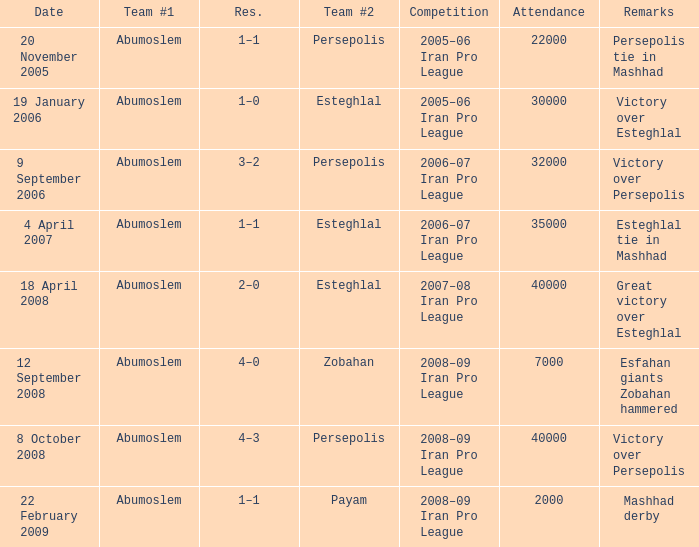On 9th september 2006, who was the number one team? Abumoslem. 